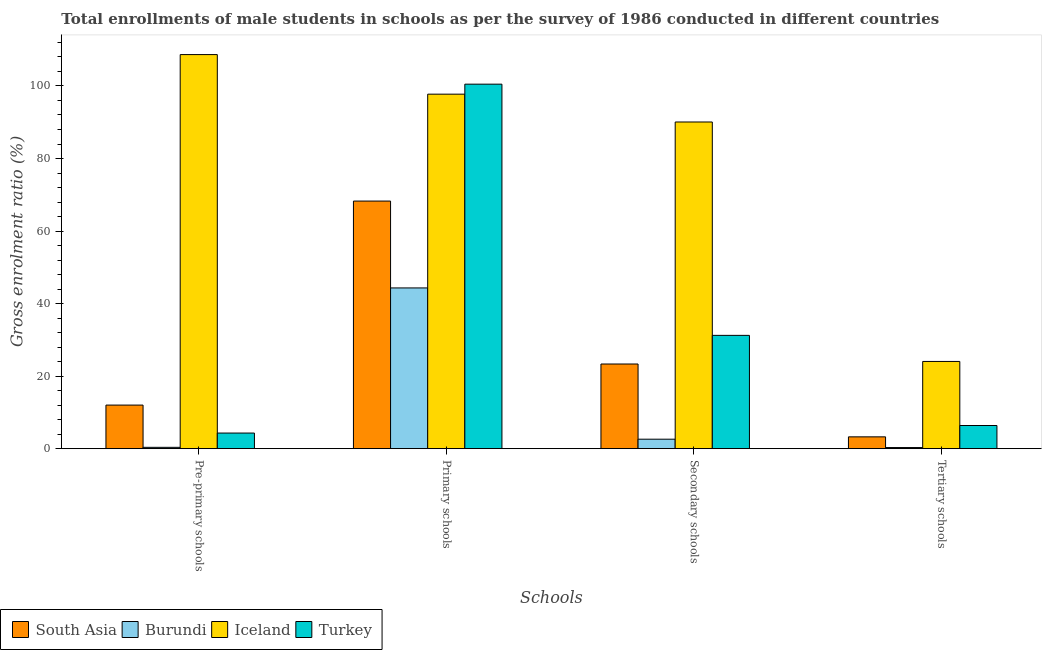How many groups of bars are there?
Keep it short and to the point. 4. Are the number of bars per tick equal to the number of legend labels?
Your answer should be compact. Yes. Are the number of bars on each tick of the X-axis equal?
Ensure brevity in your answer.  Yes. How many bars are there on the 3rd tick from the right?
Provide a short and direct response. 4. What is the label of the 2nd group of bars from the left?
Your answer should be compact. Primary schools. What is the gross enrolment ratio(male) in tertiary schools in Turkey?
Provide a succinct answer. 6.39. Across all countries, what is the maximum gross enrolment ratio(male) in primary schools?
Your response must be concise. 100.5. Across all countries, what is the minimum gross enrolment ratio(male) in secondary schools?
Give a very brief answer. 2.61. In which country was the gross enrolment ratio(male) in pre-primary schools minimum?
Ensure brevity in your answer.  Burundi. What is the total gross enrolment ratio(male) in pre-primary schools in the graph?
Ensure brevity in your answer.  125.35. What is the difference between the gross enrolment ratio(male) in primary schools in South Asia and that in Turkey?
Offer a terse response. -32.23. What is the difference between the gross enrolment ratio(male) in primary schools in Turkey and the gross enrolment ratio(male) in pre-primary schools in Iceland?
Provide a succinct answer. -8.16. What is the average gross enrolment ratio(male) in pre-primary schools per country?
Keep it short and to the point. 31.34. What is the difference between the gross enrolment ratio(male) in pre-primary schools and gross enrolment ratio(male) in secondary schools in Turkey?
Make the answer very short. -26.93. What is the ratio of the gross enrolment ratio(male) in primary schools in South Asia to that in Iceland?
Give a very brief answer. 0.7. Is the gross enrolment ratio(male) in primary schools in Turkey less than that in Iceland?
Make the answer very short. No. What is the difference between the highest and the second highest gross enrolment ratio(male) in secondary schools?
Your answer should be very brief. 58.83. What is the difference between the highest and the lowest gross enrolment ratio(male) in secondary schools?
Your response must be concise. 87.46. In how many countries, is the gross enrolment ratio(male) in primary schools greater than the average gross enrolment ratio(male) in primary schools taken over all countries?
Provide a short and direct response. 2. Is it the case that in every country, the sum of the gross enrolment ratio(male) in secondary schools and gross enrolment ratio(male) in primary schools is greater than the sum of gross enrolment ratio(male) in pre-primary schools and gross enrolment ratio(male) in tertiary schools?
Give a very brief answer. Yes. What does the 4th bar from the left in Primary schools represents?
Make the answer very short. Turkey. What does the 4th bar from the right in Primary schools represents?
Keep it short and to the point. South Asia. Is it the case that in every country, the sum of the gross enrolment ratio(male) in pre-primary schools and gross enrolment ratio(male) in primary schools is greater than the gross enrolment ratio(male) in secondary schools?
Make the answer very short. Yes. How many bars are there?
Make the answer very short. 16. How many countries are there in the graph?
Ensure brevity in your answer.  4. What is the difference between two consecutive major ticks on the Y-axis?
Offer a very short reply. 20. Are the values on the major ticks of Y-axis written in scientific E-notation?
Your answer should be compact. No. Does the graph contain any zero values?
Keep it short and to the point. No. Does the graph contain grids?
Your response must be concise. No. Where does the legend appear in the graph?
Make the answer very short. Bottom left. How many legend labels are there?
Provide a succinct answer. 4. How are the legend labels stacked?
Your answer should be compact. Horizontal. What is the title of the graph?
Your answer should be compact. Total enrollments of male students in schools as per the survey of 1986 conducted in different countries. Does "Montenegro" appear as one of the legend labels in the graph?
Ensure brevity in your answer.  No. What is the label or title of the X-axis?
Offer a very short reply. Schools. What is the Gross enrolment ratio (%) in South Asia in Pre-primary schools?
Your answer should be compact. 12.02. What is the Gross enrolment ratio (%) of Burundi in Pre-primary schools?
Ensure brevity in your answer.  0.37. What is the Gross enrolment ratio (%) in Iceland in Pre-primary schools?
Ensure brevity in your answer.  108.66. What is the Gross enrolment ratio (%) in Turkey in Pre-primary schools?
Keep it short and to the point. 4.31. What is the Gross enrolment ratio (%) of South Asia in Primary schools?
Keep it short and to the point. 68.27. What is the Gross enrolment ratio (%) of Burundi in Primary schools?
Provide a short and direct response. 44.32. What is the Gross enrolment ratio (%) in Iceland in Primary schools?
Give a very brief answer. 97.74. What is the Gross enrolment ratio (%) of Turkey in Primary schools?
Your answer should be compact. 100.5. What is the Gross enrolment ratio (%) in South Asia in Secondary schools?
Make the answer very short. 23.34. What is the Gross enrolment ratio (%) of Burundi in Secondary schools?
Offer a very short reply. 2.61. What is the Gross enrolment ratio (%) of Iceland in Secondary schools?
Your response must be concise. 90.07. What is the Gross enrolment ratio (%) in Turkey in Secondary schools?
Your answer should be compact. 31.24. What is the Gross enrolment ratio (%) in South Asia in Tertiary schools?
Offer a terse response. 3.26. What is the Gross enrolment ratio (%) in Burundi in Tertiary schools?
Offer a very short reply. 0.31. What is the Gross enrolment ratio (%) in Iceland in Tertiary schools?
Provide a short and direct response. 24.05. What is the Gross enrolment ratio (%) in Turkey in Tertiary schools?
Provide a succinct answer. 6.39. Across all Schools, what is the maximum Gross enrolment ratio (%) of South Asia?
Provide a short and direct response. 68.27. Across all Schools, what is the maximum Gross enrolment ratio (%) of Burundi?
Give a very brief answer. 44.32. Across all Schools, what is the maximum Gross enrolment ratio (%) of Iceland?
Give a very brief answer. 108.66. Across all Schools, what is the maximum Gross enrolment ratio (%) of Turkey?
Your answer should be very brief. 100.5. Across all Schools, what is the minimum Gross enrolment ratio (%) of South Asia?
Give a very brief answer. 3.26. Across all Schools, what is the minimum Gross enrolment ratio (%) of Burundi?
Your answer should be very brief. 0.31. Across all Schools, what is the minimum Gross enrolment ratio (%) in Iceland?
Provide a short and direct response. 24.05. Across all Schools, what is the minimum Gross enrolment ratio (%) of Turkey?
Offer a terse response. 4.31. What is the total Gross enrolment ratio (%) in South Asia in the graph?
Your answer should be very brief. 106.89. What is the total Gross enrolment ratio (%) in Burundi in the graph?
Provide a short and direct response. 47.61. What is the total Gross enrolment ratio (%) of Iceland in the graph?
Provide a short and direct response. 320.52. What is the total Gross enrolment ratio (%) in Turkey in the graph?
Give a very brief answer. 142.43. What is the difference between the Gross enrolment ratio (%) in South Asia in Pre-primary schools and that in Primary schools?
Offer a terse response. -56.25. What is the difference between the Gross enrolment ratio (%) in Burundi in Pre-primary schools and that in Primary schools?
Your answer should be compact. -43.95. What is the difference between the Gross enrolment ratio (%) in Iceland in Pre-primary schools and that in Primary schools?
Your answer should be compact. 10.91. What is the difference between the Gross enrolment ratio (%) of Turkey in Pre-primary schools and that in Primary schools?
Your response must be concise. -96.19. What is the difference between the Gross enrolment ratio (%) of South Asia in Pre-primary schools and that in Secondary schools?
Your answer should be very brief. -11.33. What is the difference between the Gross enrolment ratio (%) of Burundi in Pre-primary schools and that in Secondary schools?
Your response must be concise. -2.24. What is the difference between the Gross enrolment ratio (%) in Iceland in Pre-primary schools and that in Secondary schools?
Make the answer very short. 18.59. What is the difference between the Gross enrolment ratio (%) of Turkey in Pre-primary schools and that in Secondary schools?
Provide a short and direct response. -26.93. What is the difference between the Gross enrolment ratio (%) in South Asia in Pre-primary schools and that in Tertiary schools?
Make the answer very short. 8.76. What is the difference between the Gross enrolment ratio (%) of Burundi in Pre-primary schools and that in Tertiary schools?
Provide a succinct answer. 0.06. What is the difference between the Gross enrolment ratio (%) of Iceland in Pre-primary schools and that in Tertiary schools?
Provide a succinct answer. 84.61. What is the difference between the Gross enrolment ratio (%) of Turkey in Pre-primary schools and that in Tertiary schools?
Keep it short and to the point. -2.08. What is the difference between the Gross enrolment ratio (%) in South Asia in Primary schools and that in Secondary schools?
Offer a terse response. 44.92. What is the difference between the Gross enrolment ratio (%) of Burundi in Primary schools and that in Secondary schools?
Your answer should be compact. 41.71. What is the difference between the Gross enrolment ratio (%) in Iceland in Primary schools and that in Secondary schools?
Make the answer very short. 7.67. What is the difference between the Gross enrolment ratio (%) of Turkey in Primary schools and that in Secondary schools?
Your answer should be compact. 69.26. What is the difference between the Gross enrolment ratio (%) of South Asia in Primary schools and that in Tertiary schools?
Provide a succinct answer. 65.01. What is the difference between the Gross enrolment ratio (%) in Burundi in Primary schools and that in Tertiary schools?
Offer a very short reply. 44.01. What is the difference between the Gross enrolment ratio (%) of Iceland in Primary schools and that in Tertiary schools?
Provide a succinct answer. 73.69. What is the difference between the Gross enrolment ratio (%) in Turkey in Primary schools and that in Tertiary schools?
Your answer should be very brief. 94.11. What is the difference between the Gross enrolment ratio (%) in South Asia in Secondary schools and that in Tertiary schools?
Your answer should be compact. 20.09. What is the difference between the Gross enrolment ratio (%) of Burundi in Secondary schools and that in Tertiary schools?
Provide a short and direct response. 2.31. What is the difference between the Gross enrolment ratio (%) in Iceland in Secondary schools and that in Tertiary schools?
Offer a terse response. 66.02. What is the difference between the Gross enrolment ratio (%) of Turkey in Secondary schools and that in Tertiary schools?
Provide a short and direct response. 24.85. What is the difference between the Gross enrolment ratio (%) in South Asia in Pre-primary schools and the Gross enrolment ratio (%) in Burundi in Primary schools?
Provide a short and direct response. -32.3. What is the difference between the Gross enrolment ratio (%) of South Asia in Pre-primary schools and the Gross enrolment ratio (%) of Iceland in Primary schools?
Your answer should be very brief. -85.73. What is the difference between the Gross enrolment ratio (%) of South Asia in Pre-primary schools and the Gross enrolment ratio (%) of Turkey in Primary schools?
Make the answer very short. -88.48. What is the difference between the Gross enrolment ratio (%) of Burundi in Pre-primary schools and the Gross enrolment ratio (%) of Iceland in Primary schools?
Offer a very short reply. -97.37. What is the difference between the Gross enrolment ratio (%) in Burundi in Pre-primary schools and the Gross enrolment ratio (%) in Turkey in Primary schools?
Provide a succinct answer. -100.13. What is the difference between the Gross enrolment ratio (%) of Iceland in Pre-primary schools and the Gross enrolment ratio (%) of Turkey in Primary schools?
Your answer should be compact. 8.16. What is the difference between the Gross enrolment ratio (%) in South Asia in Pre-primary schools and the Gross enrolment ratio (%) in Burundi in Secondary schools?
Provide a short and direct response. 9.4. What is the difference between the Gross enrolment ratio (%) of South Asia in Pre-primary schools and the Gross enrolment ratio (%) of Iceland in Secondary schools?
Keep it short and to the point. -78.05. What is the difference between the Gross enrolment ratio (%) of South Asia in Pre-primary schools and the Gross enrolment ratio (%) of Turkey in Secondary schools?
Ensure brevity in your answer.  -19.22. What is the difference between the Gross enrolment ratio (%) in Burundi in Pre-primary schools and the Gross enrolment ratio (%) in Iceland in Secondary schools?
Ensure brevity in your answer.  -89.7. What is the difference between the Gross enrolment ratio (%) of Burundi in Pre-primary schools and the Gross enrolment ratio (%) of Turkey in Secondary schools?
Keep it short and to the point. -30.87. What is the difference between the Gross enrolment ratio (%) of Iceland in Pre-primary schools and the Gross enrolment ratio (%) of Turkey in Secondary schools?
Offer a very short reply. 77.42. What is the difference between the Gross enrolment ratio (%) of South Asia in Pre-primary schools and the Gross enrolment ratio (%) of Burundi in Tertiary schools?
Your response must be concise. 11.71. What is the difference between the Gross enrolment ratio (%) of South Asia in Pre-primary schools and the Gross enrolment ratio (%) of Iceland in Tertiary schools?
Give a very brief answer. -12.03. What is the difference between the Gross enrolment ratio (%) in South Asia in Pre-primary schools and the Gross enrolment ratio (%) in Turkey in Tertiary schools?
Give a very brief answer. 5.63. What is the difference between the Gross enrolment ratio (%) of Burundi in Pre-primary schools and the Gross enrolment ratio (%) of Iceland in Tertiary schools?
Give a very brief answer. -23.68. What is the difference between the Gross enrolment ratio (%) of Burundi in Pre-primary schools and the Gross enrolment ratio (%) of Turkey in Tertiary schools?
Ensure brevity in your answer.  -6.02. What is the difference between the Gross enrolment ratio (%) in Iceland in Pre-primary schools and the Gross enrolment ratio (%) in Turkey in Tertiary schools?
Give a very brief answer. 102.27. What is the difference between the Gross enrolment ratio (%) in South Asia in Primary schools and the Gross enrolment ratio (%) in Burundi in Secondary schools?
Your answer should be very brief. 65.65. What is the difference between the Gross enrolment ratio (%) of South Asia in Primary schools and the Gross enrolment ratio (%) of Iceland in Secondary schools?
Give a very brief answer. -21.8. What is the difference between the Gross enrolment ratio (%) in South Asia in Primary schools and the Gross enrolment ratio (%) in Turkey in Secondary schools?
Provide a succinct answer. 37.03. What is the difference between the Gross enrolment ratio (%) in Burundi in Primary schools and the Gross enrolment ratio (%) in Iceland in Secondary schools?
Give a very brief answer. -45.75. What is the difference between the Gross enrolment ratio (%) of Burundi in Primary schools and the Gross enrolment ratio (%) of Turkey in Secondary schools?
Provide a short and direct response. 13.08. What is the difference between the Gross enrolment ratio (%) in Iceland in Primary schools and the Gross enrolment ratio (%) in Turkey in Secondary schools?
Your response must be concise. 66.5. What is the difference between the Gross enrolment ratio (%) in South Asia in Primary schools and the Gross enrolment ratio (%) in Burundi in Tertiary schools?
Give a very brief answer. 67.96. What is the difference between the Gross enrolment ratio (%) in South Asia in Primary schools and the Gross enrolment ratio (%) in Iceland in Tertiary schools?
Keep it short and to the point. 44.22. What is the difference between the Gross enrolment ratio (%) in South Asia in Primary schools and the Gross enrolment ratio (%) in Turkey in Tertiary schools?
Offer a terse response. 61.88. What is the difference between the Gross enrolment ratio (%) of Burundi in Primary schools and the Gross enrolment ratio (%) of Iceland in Tertiary schools?
Your answer should be compact. 20.27. What is the difference between the Gross enrolment ratio (%) in Burundi in Primary schools and the Gross enrolment ratio (%) in Turkey in Tertiary schools?
Your response must be concise. 37.93. What is the difference between the Gross enrolment ratio (%) in Iceland in Primary schools and the Gross enrolment ratio (%) in Turkey in Tertiary schools?
Make the answer very short. 91.36. What is the difference between the Gross enrolment ratio (%) in South Asia in Secondary schools and the Gross enrolment ratio (%) in Burundi in Tertiary schools?
Ensure brevity in your answer.  23.04. What is the difference between the Gross enrolment ratio (%) of South Asia in Secondary schools and the Gross enrolment ratio (%) of Iceland in Tertiary schools?
Ensure brevity in your answer.  -0.71. What is the difference between the Gross enrolment ratio (%) of South Asia in Secondary schools and the Gross enrolment ratio (%) of Turkey in Tertiary schools?
Your response must be concise. 16.96. What is the difference between the Gross enrolment ratio (%) of Burundi in Secondary schools and the Gross enrolment ratio (%) of Iceland in Tertiary schools?
Offer a terse response. -21.44. What is the difference between the Gross enrolment ratio (%) of Burundi in Secondary schools and the Gross enrolment ratio (%) of Turkey in Tertiary schools?
Keep it short and to the point. -3.77. What is the difference between the Gross enrolment ratio (%) in Iceland in Secondary schools and the Gross enrolment ratio (%) in Turkey in Tertiary schools?
Provide a short and direct response. 83.68. What is the average Gross enrolment ratio (%) of South Asia per Schools?
Provide a short and direct response. 26.72. What is the average Gross enrolment ratio (%) of Burundi per Schools?
Your answer should be very brief. 11.9. What is the average Gross enrolment ratio (%) in Iceland per Schools?
Provide a succinct answer. 80.13. What is the average Gross enrolment ratio (%) of Turkey per Schools?
Keep it short and to the point. 35.61. What is the difference between the Gross enrolment ratio (%) in South Asia and Gross enrolment ratio (%) in Burundi in Pre-primary schools?
Make the answer very short. 11.65. What is the difference between the Gross enrolment ratio (%) of South Asia and Gross enrolment ratio (%) of Iceland in Pre-primary schools?
Give a very brief answer. -96.64. What is the difference between the Gross enrolment ratio (%) of South Asia and Gross enrolment ratio (%) of Turkey in Pre-primary schools?
Give a very brief answer. 7.71. What is the difference between the Gross enrolment ratio (%) of Burundi and Gross enrolment ratio (%) of Iceland in Pre-primary schools?
Offer a terse response. -108.29. What is the difference between the Gross enrolment ratio (%) of Burundi and Gross enrolment ratio (%) of Turkey in Pre-primary schools?
Ensure brevity in your answer.  -3.94. What is the difference between the Gross enrolment ratio (%) in Iceland and Gross enrolment ratio (%) in Turkey in Pre-primary schools?
Keep it short and to the point. 104.35. What is the difference between the Gross enrolment ratio (%) of South Asia and Gross enrolment ratio (%) of Burundi in Primary schools?
Provide a succinct answer. 23.95. What is the difference between the Gross enrolment ratio (%) of South Asia and Gross enrolment ratio (%) of Iceland in Primary schools?
Ensure brevity in your answer.  -29.48. What is the difference between the Gross enrolment ratio (%) of South Asia and Gross enrolment ratio (%) of Turkey in Primary schools?
Your answer should be compact. -32.23. What is the difference between the Gross enrolment ratio (%) of Burundi and Gross enrolment ratio (%) of Iceland in Primary schools?
Your answer should be very brief. -53.42. What is the difference between the Gross enrolment ratio (%) in Burundi and Gross enrolment ratio (%) in Turkey in Primary schools?
Offer a very short reply. -56.18. What is the difference between the Gross enrolment ratio (%) in Iceland and Gross enrolment ratio (%) in Turkey in Primary schools?
Provide a short and direct response. -2.76. What is the difference between the Gross enrolment ratio (%) in South Asia and Gross enrolment ratio (%) in Burundi in Secondary schools?
Your response must be concise. 20.73. What is the difference between the Gross enrolment ratio (%) in South Asia and Gross enrolment ratio (%) in Iceland in Secondary schools?
Provide a succinct answer. -66.73. What is the difference between the Gross enrolment ratio (%) in South Asia and Gross enrolment ratio (%) in Turkey in Secondary schools?
Provide a succinct answer. -7.89. What is the difference between the Gross enrolment ratio (%) in Burundi and Gross enrolment ratio (%) in Iceland in Secondary schools?
Your answer should be compact. -87.46. What is the difference between the Gross enrolment ratio (%) of Burundi and Gross enrolment ratio (%) of Turkey in Secondary schools?
Offer a terse response. -28.63. What is the difference between the Gross enrolment ratio (%) of Iceland and Gross enrolment ratio (%) of Turkey in Secondary schools?
Your answer should be very brief. 58.83. What is the difference between the Gross enrolment ratio (%) of South Asia and Gross enrolment ratio (%) of Burundi in Tertiary schools?
Your answer should be very brief. 2.95. What is the difference between the Gross enrolment ratio (%) in South Asia and Gross enrolment ratio (%) in Iceland in Tertiary schools?
Your answer should be compact. -20.79. What is the difference between the Gross enrolment ratio (%) of South Asia and Gross enrolment ratio (%) of Turkey in Tertiary schools?
Provide a short and direct response. -3.13. What is the difference between the Gross enrolment ratio (%) of Burundi and Gross enrolment ratio (%) of Iceland in Tertiary schools?
Make the answer very short. -23.74. What is the difference between the Gross enrolment ratio (%) of Burundi and Gross enrolment ratio (%) of Turkey in Tertiary schools?
Keep it short and to the point. -6.08. What is the difference between the Gross enrolment ratio (%) in Iceland and Gross enrolment ratio (%) in Turkey in Tertiary schools?
Provide a short and direct response. 17.66. What is the ratio of the Gross enrolment ratio (%) in South Asia in Pre-primary schools to that in Primary schools?
Keep it short and to the point. 0.18. What is the ratio of the Gross enrolment ratio (%) of Burundi in Pre-primary schools to that in Primary schools?
Offer a terse response. 0.01. What is the ratio of the Gross enrolment ratio (%) in Iceland in Pre-primary schools to that in Primary schools?
Ensure brevity in your answer.  1.11. What is the ratio of the Gross enrolment ratio (%) in Turkey in Pre-primary schools to that in Primary schools?
Keep it short and to the point. 0.04. What is the ratio of the Gross enrolment ratio (%) in South Asia in Pre-primary schools to that in Secondary schools?
Your response must be concise. 0.51. What is the ratio of the Gross enrolment ratio (%) of Burundi in Pre-primary schools to that in Secondary schools?
Provide a short and direct response. 0.14. What is the ratio of the Gross enrolment ratio (%) of Iceland in Pre-primary schools to that in Secondary schools?
Provide a succinct answer. 1.21. What is the ratio of the Gross enrolment ratio (%) in Turkey in Pre-primary schools to that in Secondary schools?
Your answer should be compact. 0.14. What is the ratio of the Gross enrolment ratio (%) in South Asia in Pre-primary schools to that in Tertiary schools?
Your response must be concise. 3.69. What is the ratio of the Gross enrolment ratio (%) in Burundi in Pre-primary schools to that in Tertiary schools?
Ensure brevity in your answer.  1.2. What is the ratio of the Gross enrolment ratio (%) of Iceland in Pre-primary schools to that in Tertiary schools?
Your answer should be very brief. 4.52. What is the ratio of the Gross enrolment ratio (%) in Turkey in Pre-primary schools to that in Tertiary schools?
Your answer should be very brief. 0.67. What is the ratio of the Gross enrolment ratio (%) in South Asia in Primary schools to that in Secondary schools?
Your answer should be very brief. 2.92. What is the ratio of the Gross enrolment ratio (%) of Burundi in Primary schools to that in Secondary schools?
Offer a very short reply. 16.97. What is the ratio of the Gross enrolment ratio (%) of Iceland in Primary schools to that in Secondary schools?
Your answer should be very brief. 1.09. What is the ratio of the Gross enrolment ratio (%) of Turkey in Primary schools to that in Secondary schools?
Provide a succinct answer. 3.22. What is the ratio of the Gross enrolment ratio (%) of South Asia in Primary schools to that in Tertiary schools?
Your response must be concise. 20.94. What is the ratio of the Gross enrolment ratio (%) of Burundi in Primary schools to that in Tertiary schools?
Your response must be concise. 144.35. What is the ratio of the Gross enrolment ratio (%) of Iceland in Primary schools to that in Tertiary schools?
Keep it short and to the point. 4.06. What is the ratio of the Gross enrolment ratio (%) of Turkey in Primary schools to that in Tertiary schools?
Ensure brevity in your answer.  15.74. What is the ratio of the Gross enrolment ratio (%) in South Asia in Secondary schools to that in Tertiary schools?
Give a very brief answer. 7.16. What is the ratio of the Gross enrolment ratio (%) of Burundi in Secondary schools to that in Tertiary schools?
Ensure brevity in your answer.  8.51. What is the ratio of the Gross enrolment ratio (%) of Iceland in Secondary schools to that in Tertiary schools?
Your response must be concise. 3.75. What is the ratio of the Gross enrolment ratio (%) in Turkey in Secondary schools to that in Tertiary schools?
Offer a terse response. 4.89. What is the difference between the highest and the second highest Gross enrolment ratio (%) in South Asia?
Ensure brevity in your answer.  44.92. What is the difference between the highest and the second highest Gross enrolment ratio (%) of Burundi?
Give a very brief answer. 41.71. What is the difference between the highest and the second highest Gross enrolment ratio (%) in Iceland?
Your response must be concise. 10.91. What is the difference between the highest and the second highest Gross enrolment ratio (%) in Turkey?
Make the answer very short. 69.26. What is the difference between the highest and the lowest Gross enrolment ratio (%) in South Asia?
Give a very brief answer. 65.01. What is the difference between the highest and the lowest Gross enrolment ratio (%) in Burundi?
Offer a very short reply. 44.01. What is the difference between the highest and the lowest Gross enrolment ratio (%) in Iceland?
Keep it short and to the point. 84.61. What is the difference between the highest and the lowest Gross enrolment ratio (%) of Turkey?
Your answer should be very brief. 96.19. 